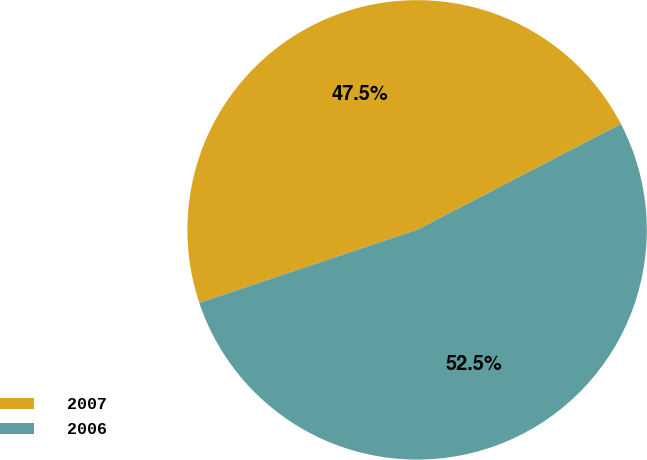<chart> <loc_0><loc_0><loc_500><loc_500><pie_chart><fcel>2007<fcel>2006<nl><fcel>47.52%<fcel>52.48%<nl></chart> 